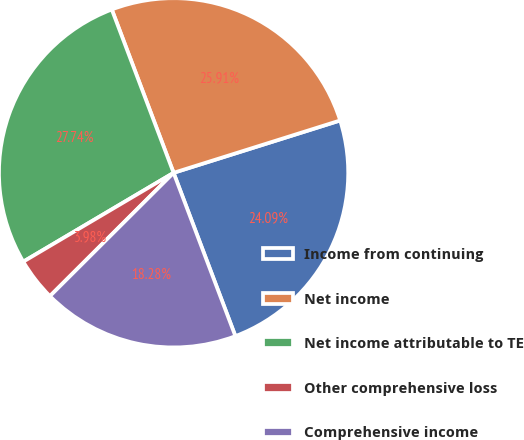<chart> <loc_0><loc_0><loc_500><loc_500><pie_chart><fcel>Income from continuing<fcel>Net income<fcel>Net income attributable to TE<fcel>Other comprehensive loss<fcel>Comprehensive income<nl><fcel>24.09%<fcel>25.91%<fcel>27.74%<fcel>3.98%<fcel>18.28%<nl></chart> 